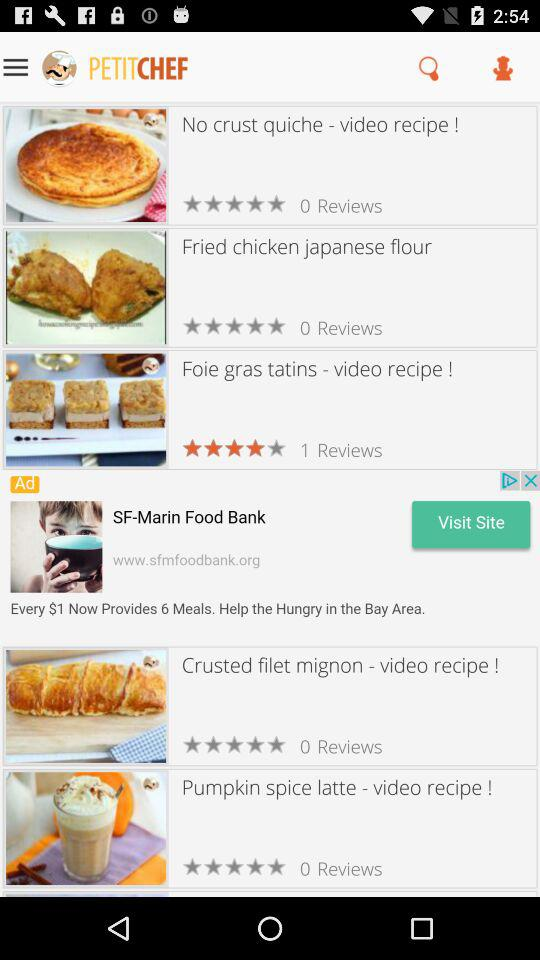What is the rating of the "Foie gras tatins"? The rating is 4 stars. 